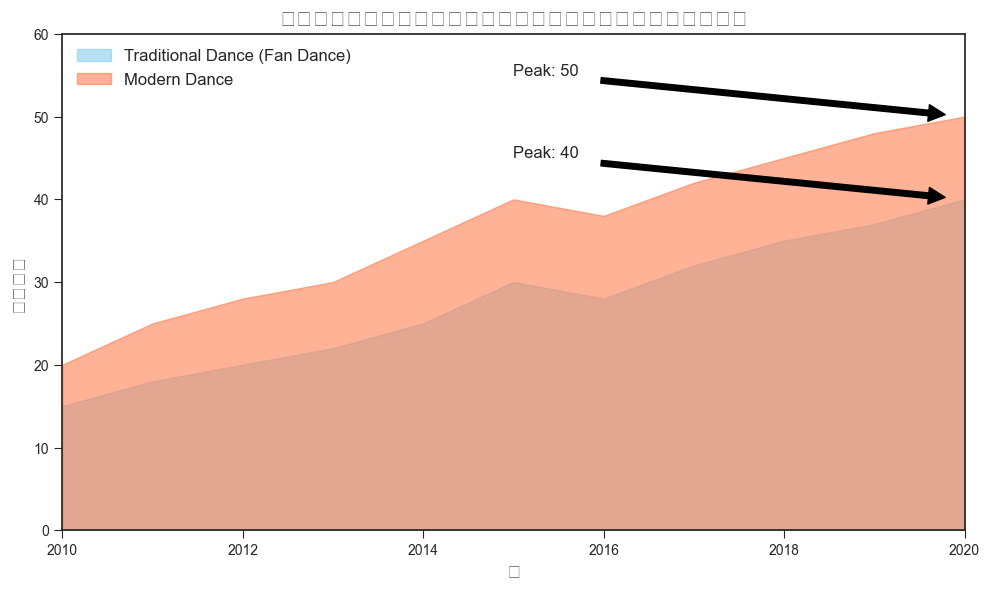Which year shows the highest frequency for both traditional and modern dance performances? For traditional dance, the highest frequency is 40 in the year 2020. Similarly, for modern dance, the highest frequency is 50, which is also in 2020. Thus, the year showing the highest frequency for both dance types is 2020.
Answer: 2020 What is the difference in peak performance frequencies between traditional and modern dance? The highest frequency for traditional dance is 40, while for modern dance it is 50. The difference is 50 - 40 = 10.
Answer: 10 In which years did the frequency of traditional dance performances increase compared to the previous year? By checking each year: 2011 (15 to 18), 2012 (18 to 20), 2013 (20 to 22), 2014 (22 to 25), 2015 (25 to 30), 2017 (28 to 32), 2018 (32 to 35), 2019 (35 to 37), and 2020 (37 to 40). Thus, the years are 2011, 2012, 2013, 2014, 2015, 2017, 2018, 2019, and 2020.
Answer: 2011, 2012, 2013, 2014, 2015, 2017, 2018, 2019, 2020 Which dance form showed more consistent growth throughout the decade: traditional dance or modern dance? Traditional dance shows periods of both increase and decrease, while modern dance shows a consistent increase every year from 20 in 2010 to 50 in 2020. Thus, modern dance demonstrated more consistent growth.
Answer: Modern dance On average, how many performances did modern dance have per year over the decade? Sum the modern dance frequencies from 2010 to 2020: 20 + 25 + 28 + 30 + 35 + 40 + 38 + 42 + 45 + 48 + 50 = 401. Then, divide by the number of years (11): 401 / 11 ≈ 36.45.
Answer: 36.45 What are the respective average frequencies of traditional and modern dance performances over the decade? For traditional dance: sum (15 + 18 + 20 + 22 + 25 + 30 + 28 + 32 + 35 + 37 + 40) = 302, average = 302 / 11 ≈ 27.45. For modern dance: sum (20 + 25 + 28 + 30 + 35 + 40 + 38 + 42 + 45 + 48 + 50) = 401, average = 401 / 11 ≈ 36.45.
Answer: 27.45, 36.45 